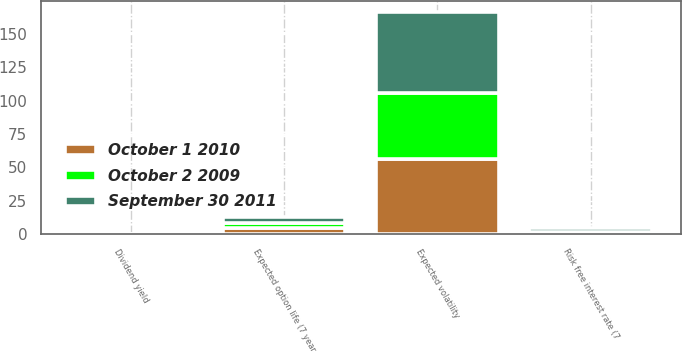Convert chart. <chart><loc_0><loc_0><loc_500><loc_500><stacked_bar_chart><ecel><fcel>Expected volatility<fcel>Risk free interest rate (7<fcel>Dividend yield<fcel>Expected option life (7 year<nl><fcel>October 2 2009<fcel>49.26<fcel>0.63<fcel>0<fcel>4.1<nl><fcel>October 1 2010<fcel>56.19<fcel>1.12<fcel>0<fcel>4.23<nl><fcel>September 30 2011<fcel>60.9<fcel>2.36<fcel>0<fcel>4.42<nl></chart> 